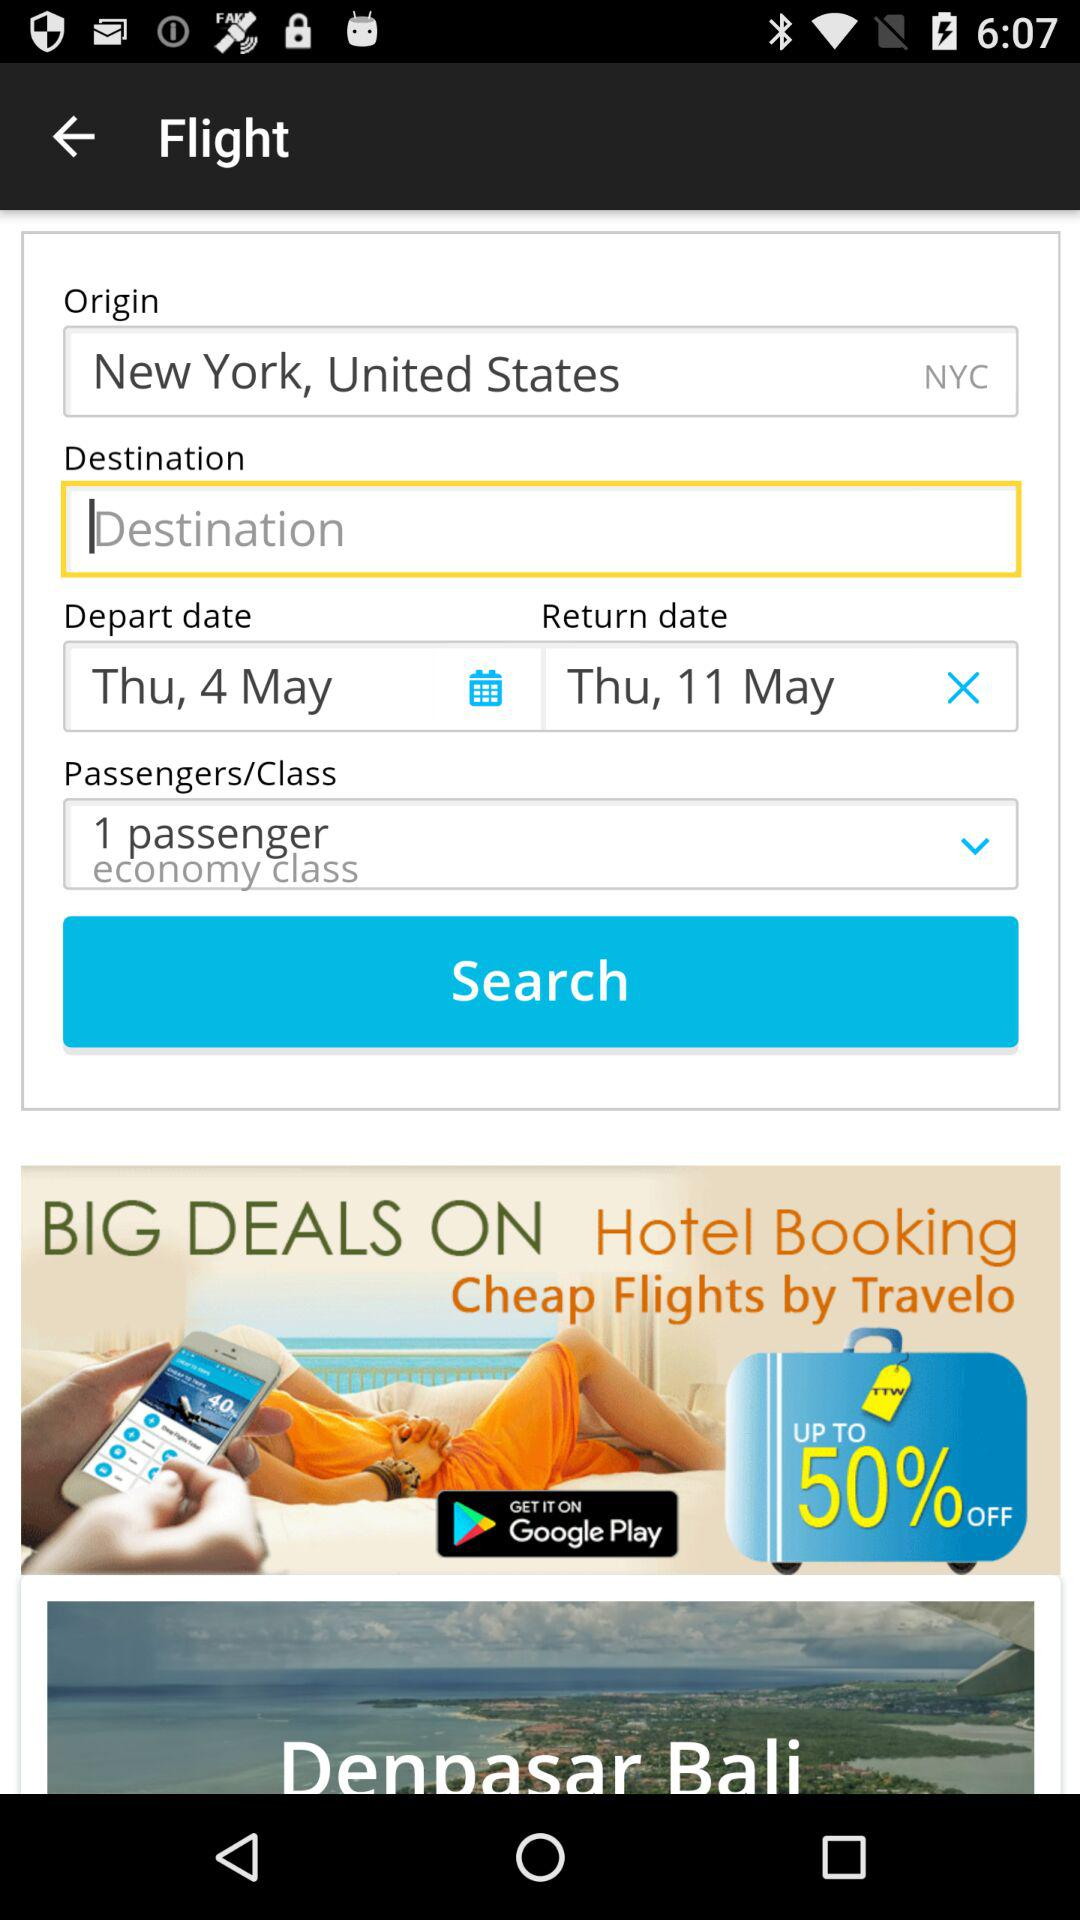What is the origin? The origin is New York, United States. 